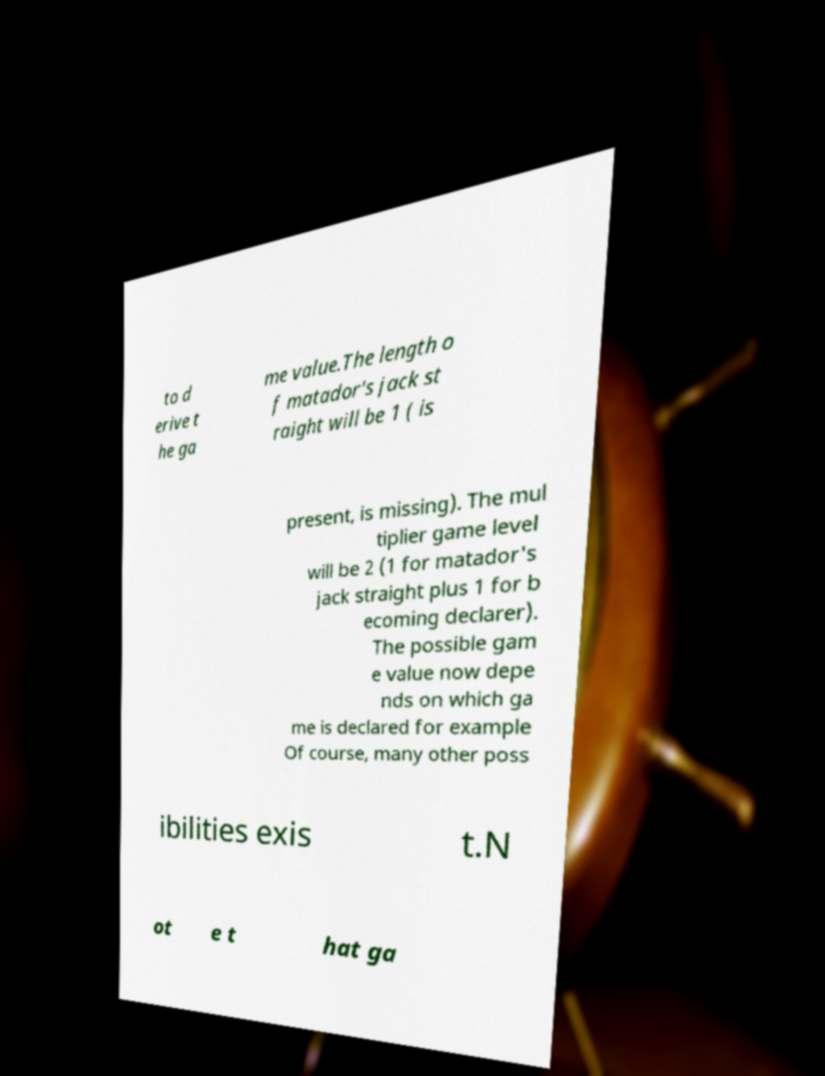There's text embedded in this image that I need extracted. Can you transcribe it verbatim? to d erive t he ga me value.The length o f matador's jack st raight will be 1 ( is present, is missing). The mul tiplier game level will be 2 (1 for matador's jack straight plus 1 for b ecoming declarer). The possible gam e value now depe nds on which ga me is declared for example Of course, many other poss ibilities exis t.N ot e t hat ga 